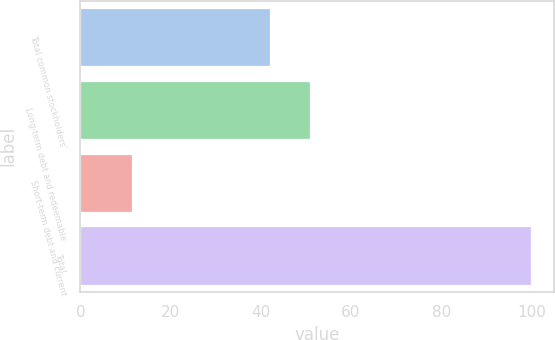<chart> <loc_0><loc_0><loc_500><loc_500><bar_chart><fcel>Total common stockholders'<fcel>Long-term debt and redeemable<fcel>Short-term debt and current<fcel>Total<nl><fcel>42.1<fcel>50.95<fcel>11.5<fcel>100<nl></chart> 